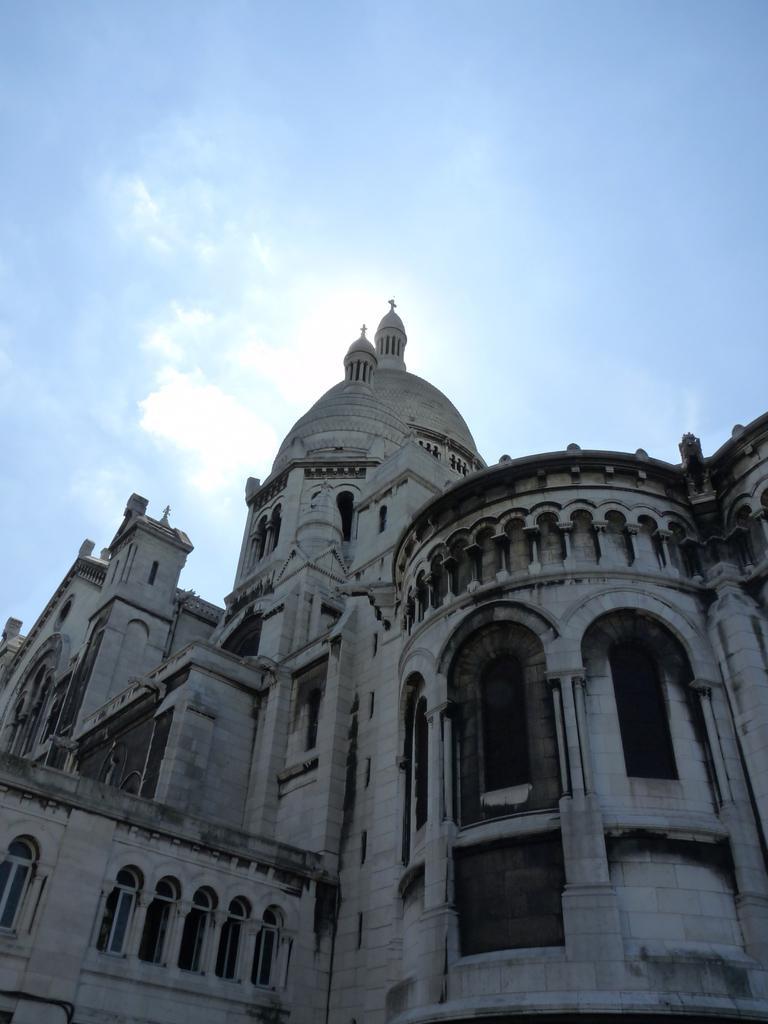Could you give a brief overview of what you see in this image? There is a building at the bottom of this image, and there is a sky in the background. 